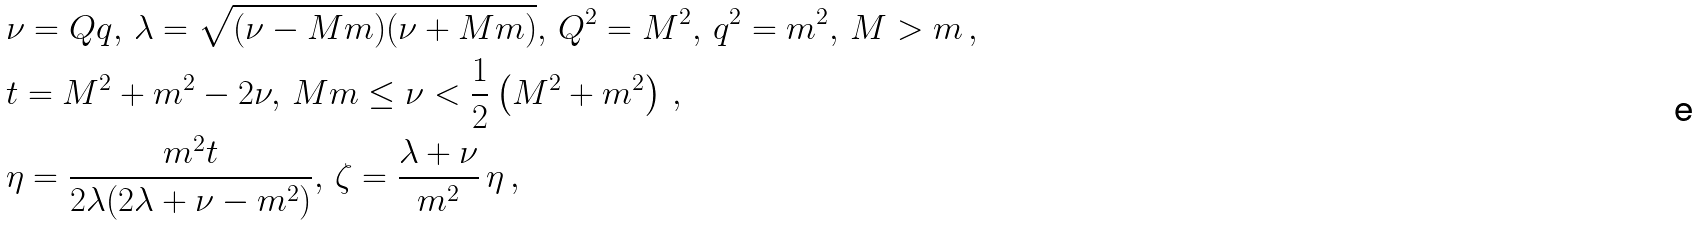<formula> <loc_0><loc_0><loc_500><loc_500>\, & \nu = Q q , \, \lambda = \sqrt { ( \nu - M m ) ( \nu + M m ) } , \, Q ^ { 2 } = M ^ { 2 } , \, q ^ { 2 } = m ^ { 2 } , \, M > m \, , \\ \, & t = M ^ { 2 } + m ^ { 2 } - 2 \nu , \, M m \leq \nu < \frac { 1 } { 2 } \left ( M ^ { 2 } + m ^ { 2 } \right ) \, , \\ \, & \eta = \frac { m ^ { 2 } t } { 2 \lambda ( 2 \lambda + \nu - m ^ { 2 } ) } , \, \zeta = \frac { \lambda + \nu } { m ^ { 2 } } \, \eta \, ,</formula> 